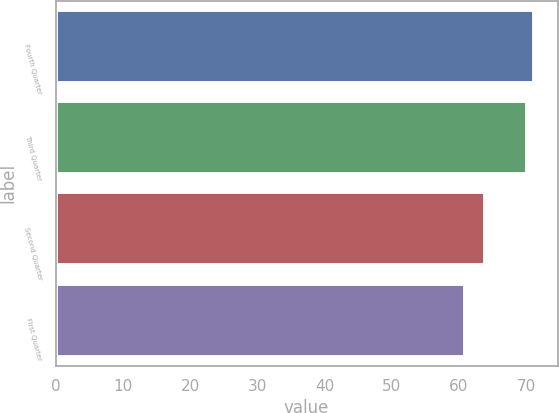Convert chart. <chart><loc_0><loc_0><loc_500><loc_500><bar_chart><fcel>Fourth Quarter<fcel>Third Quarter<fcel>Second Quarter<fcel>First Quarter<nl><fcel>71.12<fcel>70.18<fcel>63.85<fcel>60.84<nl></chart> 